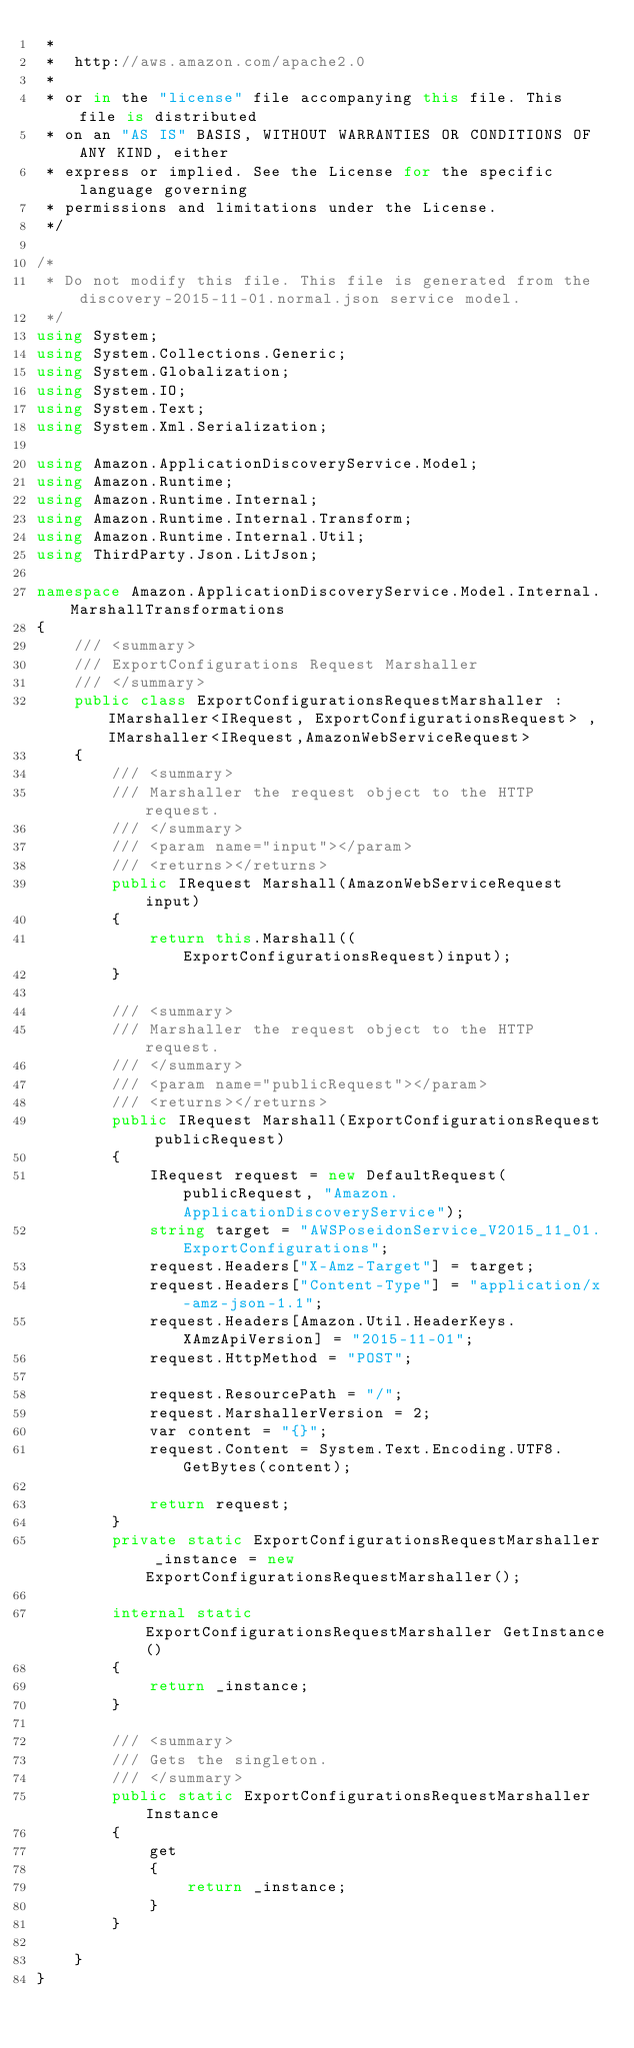<code> <loc_0><loc_0><loc_500><loc_500><_C#_> * 
 *  http://aws.amazon.com/apache2.0
 * 
 * or in the "license" file accompanying this file. This file is distributed
 * on an "AS IS" BASIS, WITHOUT WARRANTIES OR CONDITIONS OF ANY KIND, either
 * express or implied. See the License for the specific language governing
 * permissions and limitations under the License.
 */

/*
 * Do not modify this file. This file is generated from the discovery-2015-11-01.normal.json service model.
 */
using System;
using System.Collections.Generic;
using System.Globalization;
using System.IO;
using System.Text;
using System.Xml.Serialization;

using Amazon.ApplicationDiscoveryService.Model;
using Amazon.Runtime;
using Amazon.Runtime.Internal;
using Amazon.Runtime.Internal.Transform;
using Amazon.Runtime.Internal.Util;
using ThirdParty.Json.LitJson;

namespace Amazon.ApplicationDiscoveryService.Model.Internal.MarshallTransformations
{
    /// <summary>
    /// ExportConfigurations Request Marshaller
    /// </summary>       
    public class ExportConfigurationsRequestMarshaller : IMarshaller<IRequest, ExportConfigurationsRequest> , IMarshaller<IRequest,AmazonWebServiceRequest>
    {
        /// <summary>
        /// Marshaller the request object to the HTTP request.
        /// </summary>  
        /// <param name="input"></param>
        /// <returns></returns>
        public IRequest Marshall(AmazonWebServiceRequest input)
        {
            return this.Marshall((ExportConfigurationsRequest)input);
        }

        /// <summary>
        /// Marshaller the request object to the HTTP request.
        /// </summary>  
        /// <param name="publicRequest"></param>
        /// <returns></returns>
        public IRequest Marshall(ExportConfigurationsRequest publicRequest)
        {
            IRequest request = new DefaultRequest(publicRequest, "Amazon.ApplicationDiscoveryService");
            string target = "AWSPoseidonService_V2015_11_01.ExportConfigurations";
            request.Headers["X-Amz-Target"] = target;
            request.Headers["Content-Type"] = "application/x-amz-json-1.1";
            request.Headers[Amazon.Util.HeaderKeys.XAmzApiVersion] = "2015-11-01";            
            request.HttpMethod = "POST";

            request.ResourcePath = "/";
            request.MarshallerVersion = 2;
            var content = "{}";
            request.Content = System.Text.Encoding.UTF8.GetBytes(content);

            return request;
        }
        private static ExportConfigurationsRequestMarshaller _instance = new ExportConfigurationsRequestMarshaller();        

        internal static ExportConfigurationsRequestMarshaller GetInstance()
        {
            return _instance;
        }

        /// <summary>
        /// Gets the singleton.
        /// </summary>  
        public static ExportConfigurationsRequestMarshaller Instance
        {
            get
            {
                return _instance;
            }
        }

    }
}</code> 